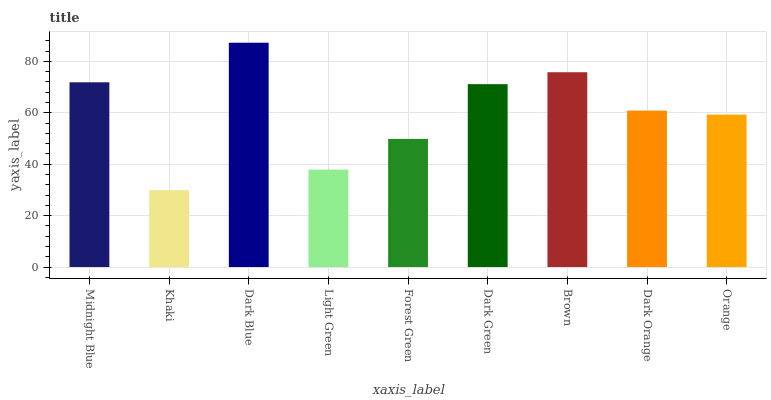Is Khaki the minimum?
Answer yes or no. Yes. Is Dark Blue the maximum?
Answer yes or no. Yes. Is Dark Blue the minimum?
Answer yes or no. No. Is Khaki the maximum?
Answer yes or no. No. Is Dark Blue greater than Khaki?
Answer yes or no. Yes. Is Khaki less than Dark Blue?
Answer yes or no. Yes. Is Khaki greater than Dark Blue?
Answer yes or no. No. Is Dark Blue less than Khaki?
Answer yes or no. No. Is Dark Orange the high median?
Answer yes or no. Yes. Is Dark Orange the low median?
Answer yes or no. Yes. Is Dark Green the high median?
Answer yes or no. No. Is Dark Blue the low median?
Answer yes or no. No. 